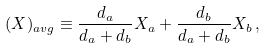Convert formula to latex. <formula><loc_0><loc_0><loc_500><loc_500>( X ) _ { a v g } \equiv \frac { d _ { a } } { d _ { a } + d _ { b } } X _ { a } + \frac { d _ { b } } { d _ { a } + d _ { b } } X _ { b } \, ,</formula> 